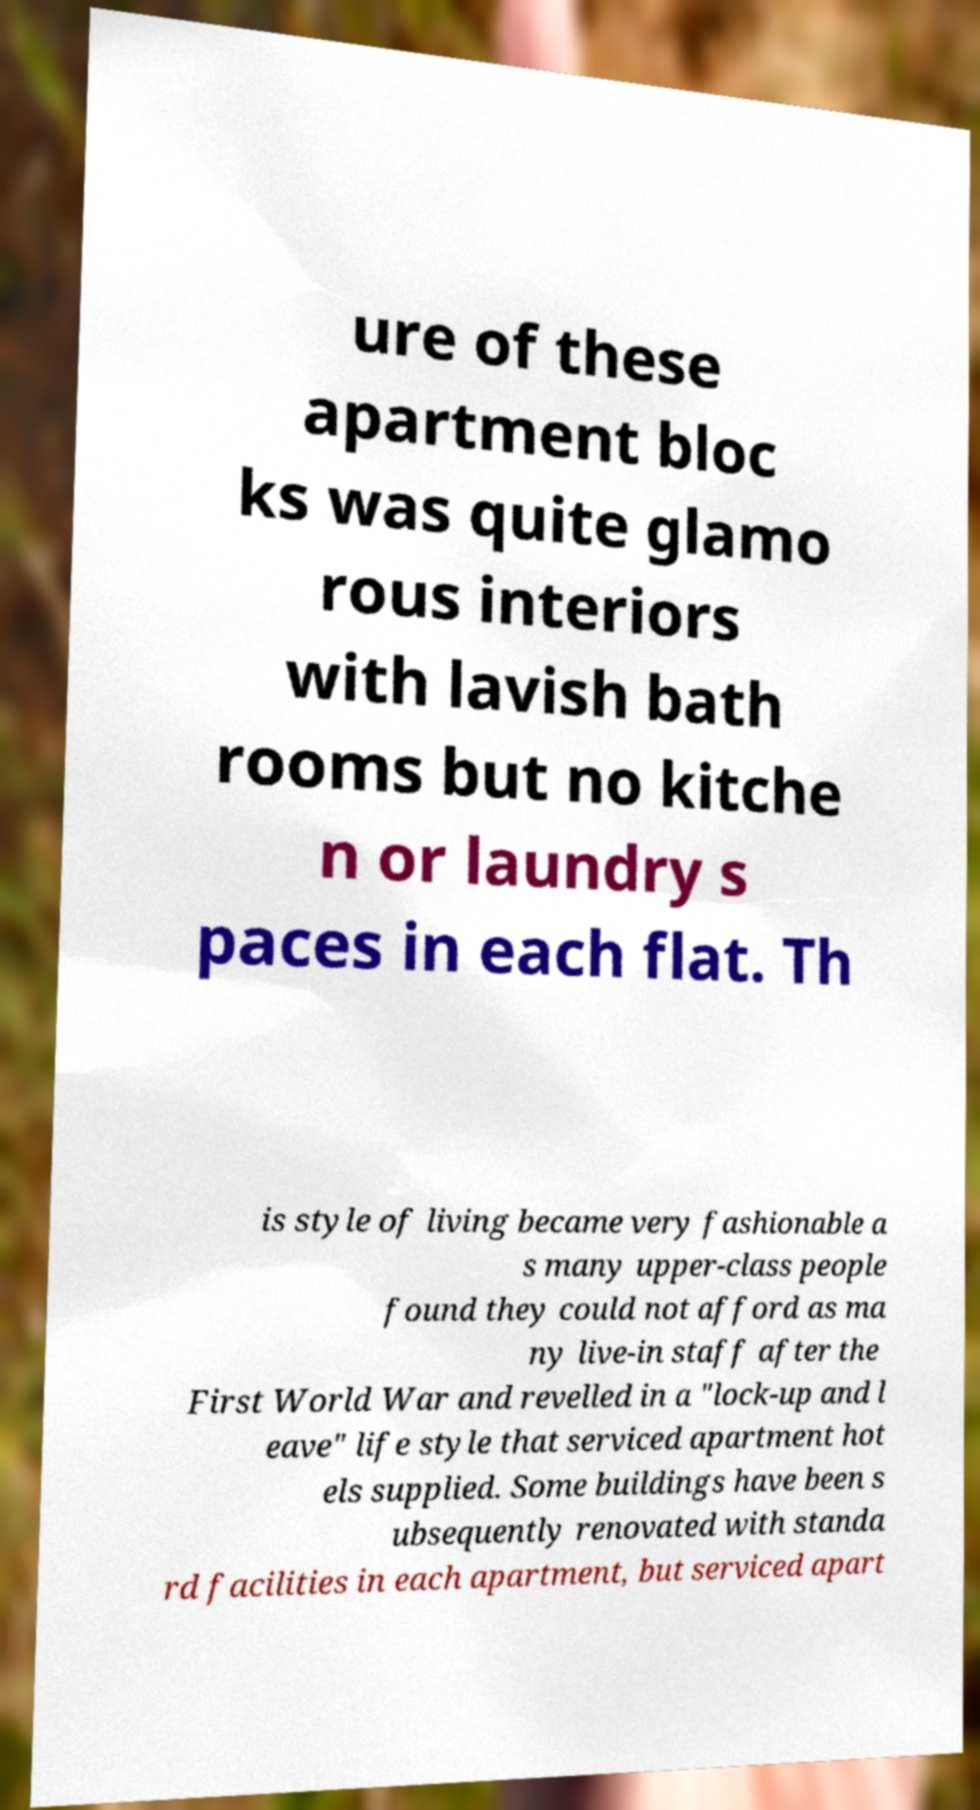Can you accurately transcribe the text from the provided image for me? ure of these apartment bloc ks was quite glamo rous interiors with lavish bath rooms but no kitche n or laundry s paces in each flat. Th is style of living became very fashionable a s many upper-class people found they could not afford as ma ny live-in staff after the First World War and revelled in a "lock-up and l eave" life style that serviced apartment hot els supplied. Some buildings have been s ubsequently renovated with standa rd facilities in each apartment, but serviced apart 